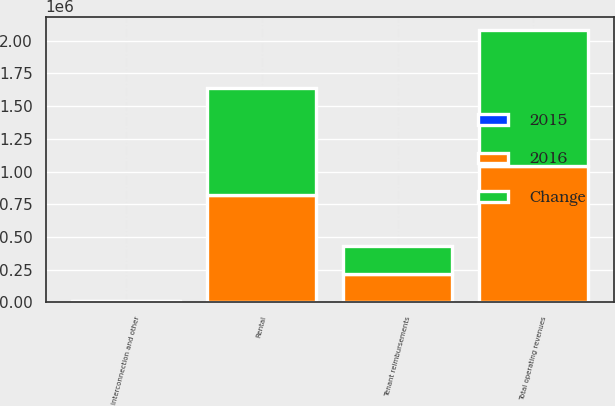<chart> <loc_0><loc_0><loc_500><loc_500><stacked_bar_chart><ecel><fcel>Rental<fcel>Tenant reimbursements<fcel>Interconnection and other<fcel>Total operating revenues<nl><fcel>2016<fcel>819848<fcel>213117<fcel>6509<fcel>1.03947e+06<nl><fcel>Change<fcel>820862<fcel>214079<fcel>5257<fcel>1.0402e+06<nl><fcel>2015<fcel>1014<fcel>962<fcel>1252<fcel>724<nl></chart> 